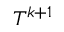Convert formula to latex. <formula><loc_0><loc_0><loc_500><loc_500>T ^ { k + 1 }</formula> 